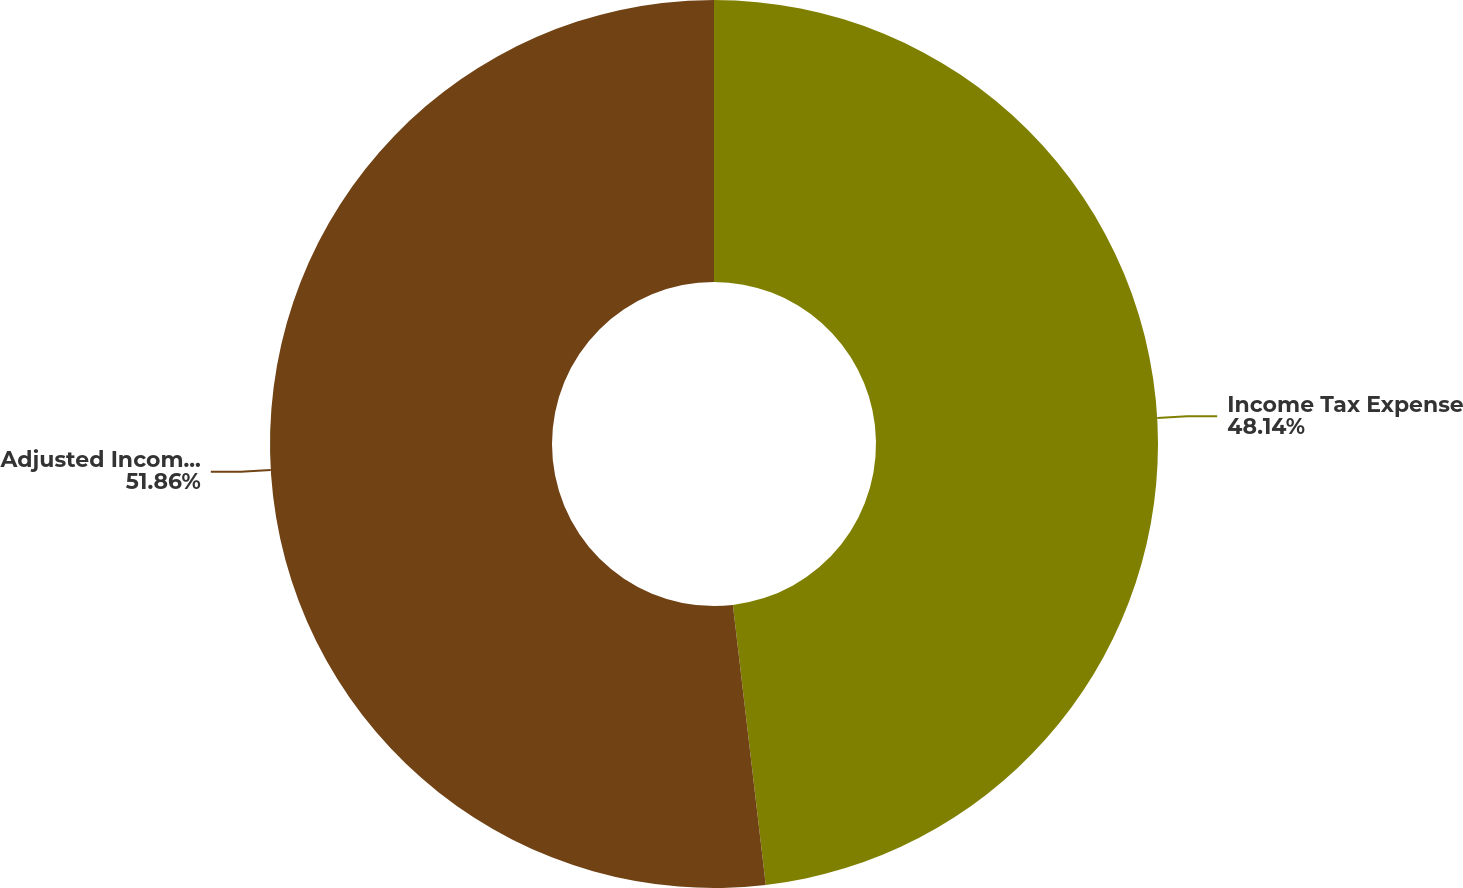<chart> <loc_0><loc_0><loc_500><loc_500><pie_chart><fcel>Income Tax Expense<fcel>Adjusted Income Tax Expense<nl><fcel>48.14%<fcel>51.86%<nl></chart> 